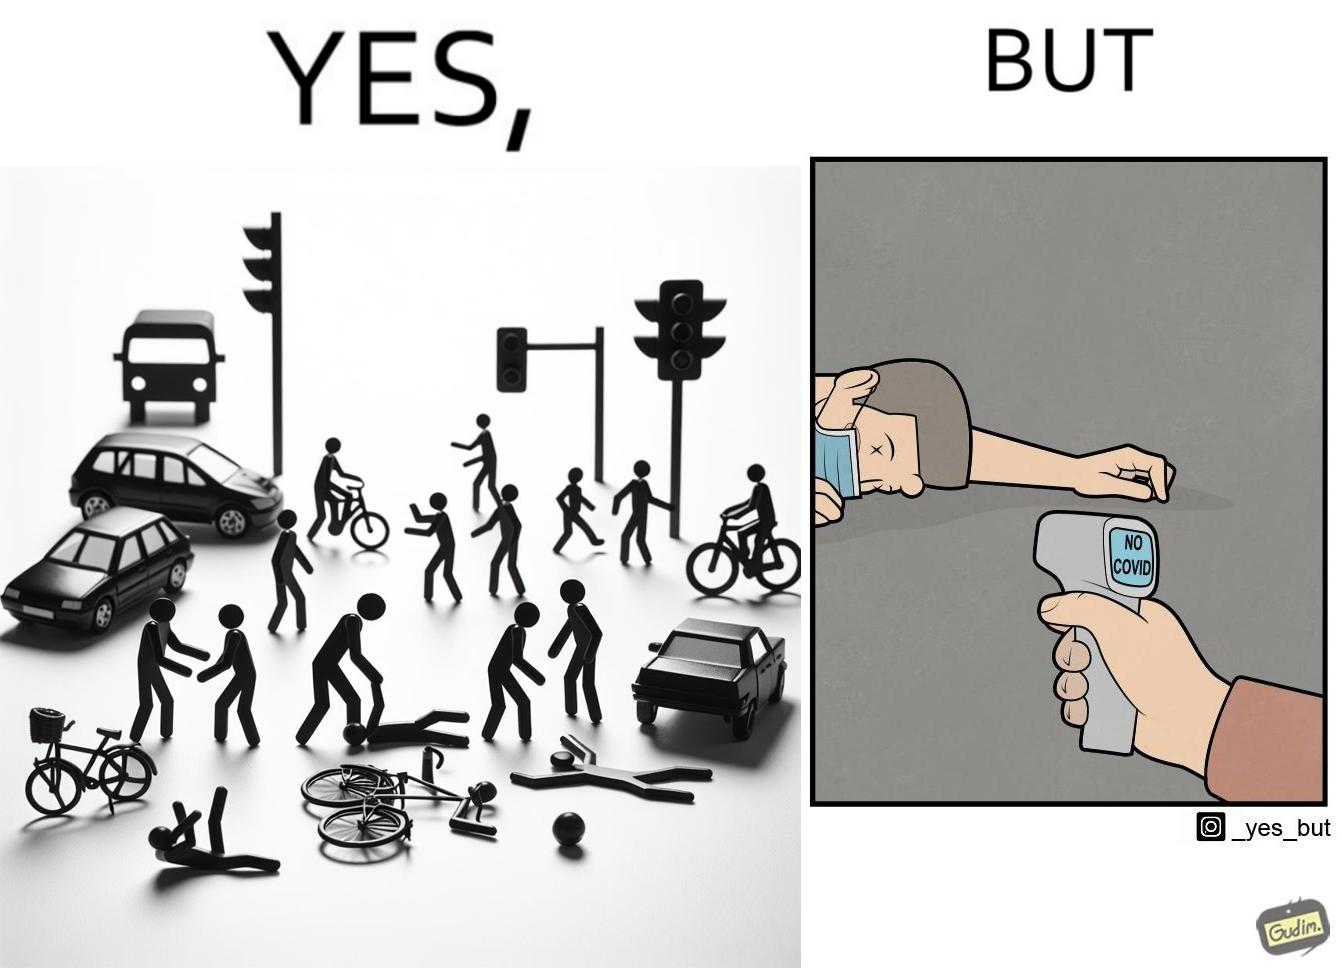Describe what you see in the left and right parts of this image. In the left part of the image: a person undergoing a road accident In the right part of the image: a person scanning a dead person for COVID 